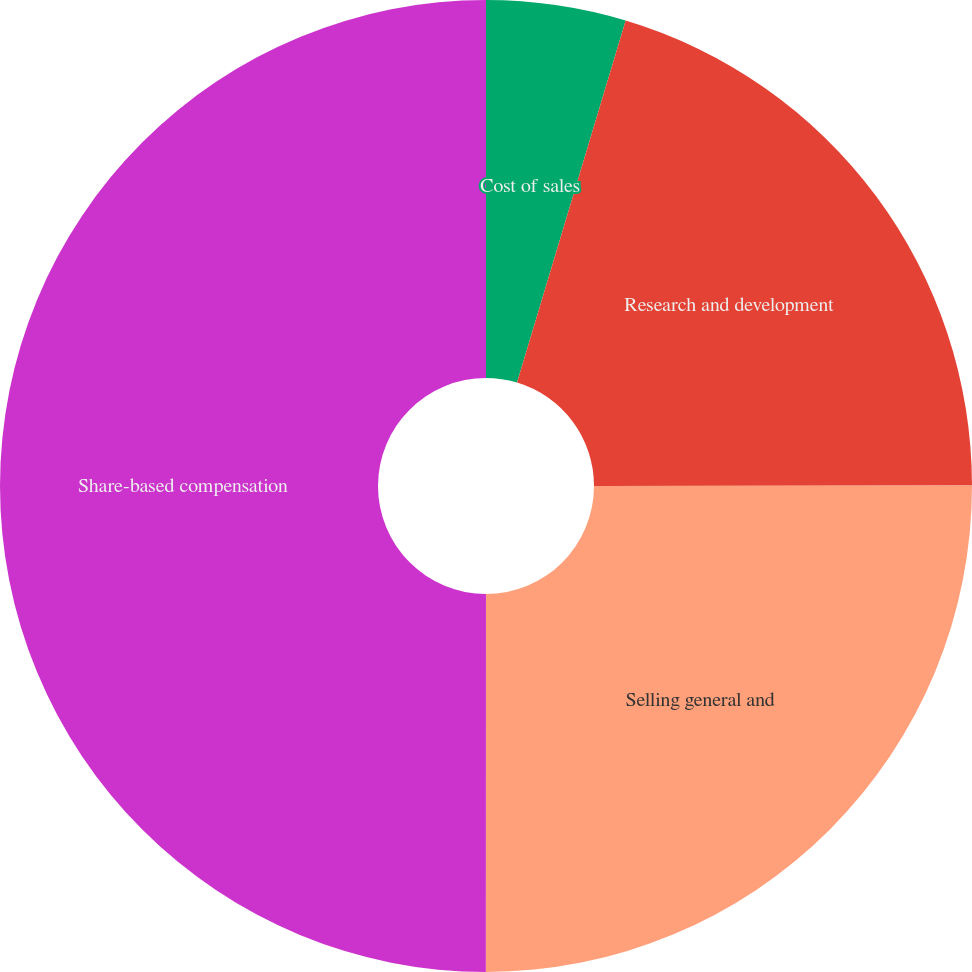<chart> <loc_0><loc_0><loc_500><loc_500><pie_chart><fcel>Cost of sales<fcel>Research and development<fcel>Selling general and<fcel>Share-based compensation<nl><fcel>4.64%<fcel>20.35%<fcel>25.02%<fcel>50.0%<nl></chart> 